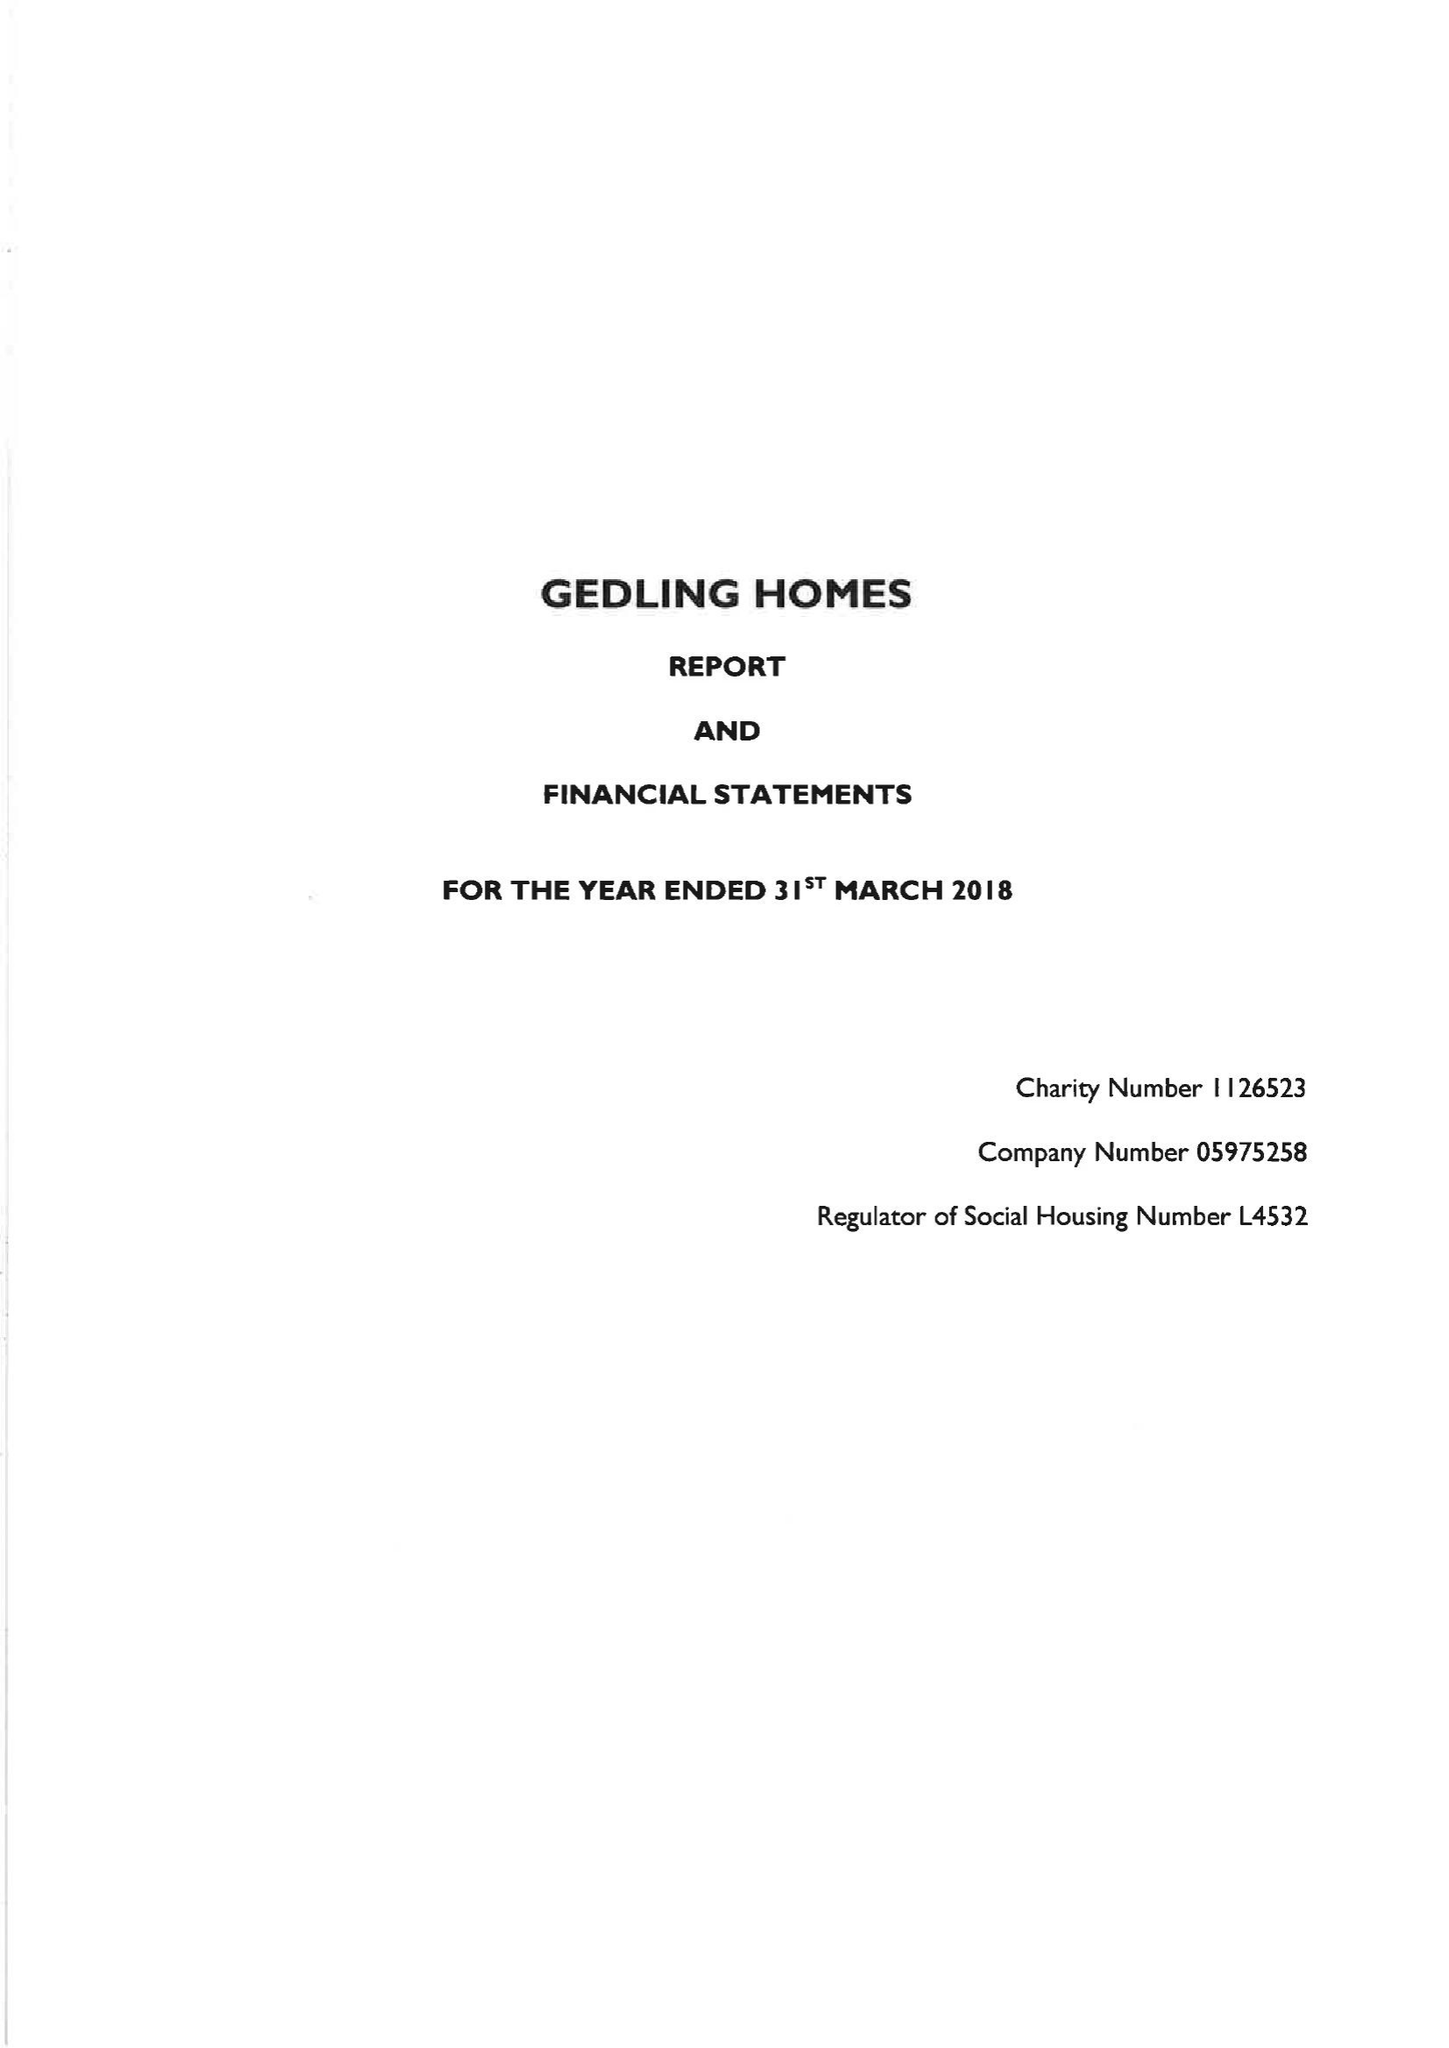What is the value for the address__street_line?
Answer the question using a single word or phrase. CAVENDISH STREET 